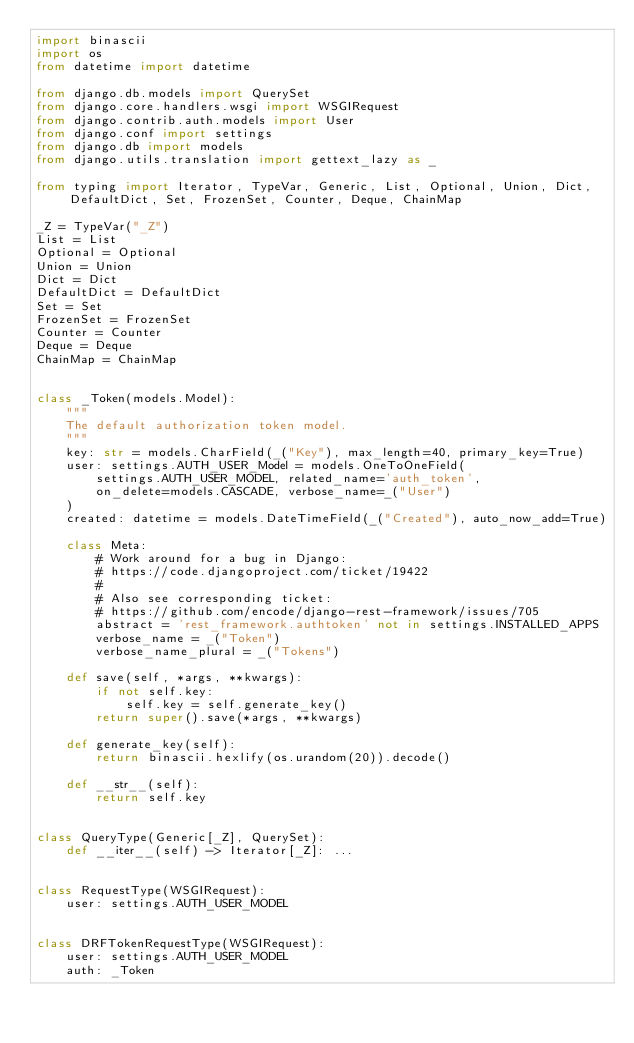<code> <loc_0><loc_0><loc_500><loc_500><_Python_>import binascii
import os
from datetime import datetime

from django.db.models import QuerySet
from django.core.handlers.wsgi import WSGIRequest
from django.contrib.auth.models import User
from django.conf import settings
from django.db import models
from django.utils.translation import gettext_lazy as _

from typing import Iterator, TypeVar, Generic, List, Optional, Union, Dict, DefaultDict, Set, FrozenSet, Counter, Deque, ChainMap

_Z = TypeVar("_Z")
List = List
Optional = Optional
Union = Union
Dict = Dict
DefaultDict = DefaultDict
Set = Set
FrozenSet = FrozenSet
Counter = Counter
Deque = Deque
ChainMap = ChainMap


class _Token(models.Model):
    """
    The default authorization token model.
    """
    key: str = models.CharField(_("Key"), max_length=40, primary_key=True)
    user: settings.AUTH_USER_Model = models.OneToOneField(
        settings.AUTH_USER_MODEL, related_name='auth_token',
        on_delete=models.CASCADE, verbose_name=_("User")
    )
    created: datetime = models.DateTimeField(_("Created"), auto_now_add=True)

    class Meta:
        # Work around for a bug in Django:
        # https://code.djangoproject.com/ticket/19422
        #
        # Also see corresponding ticket:
        # https://github.com/encode/django-rest-framework/issues/705
        abstract = 'rest_framework.authtoken' not in settings.INSTALLED_APPS
        verbose_name = _("Token")
        verbose_name_plural = _("Tokens")

    def save(self, *args, **kwargs):
        if not self.key:
            self.key = self.generate_key()
        return super().save(*args, **kwargs)

    def generate_key(self):
        return binascii.hexlify(os.urandom(20)).decode()

    def __str__(self):
        return self.key


class QueryType(Generic[_Z], QuerySet):
    def __iter__(self) -> Iterator[_Z]: ...


class RequestType(WSGIRequest):
    user: settings.AUTH_USER_MODEL


class DRFTokenRequestType(WSGIRequest):
    user: settings.AUTH_USER_MODEL
    auth: _Token
</code> 